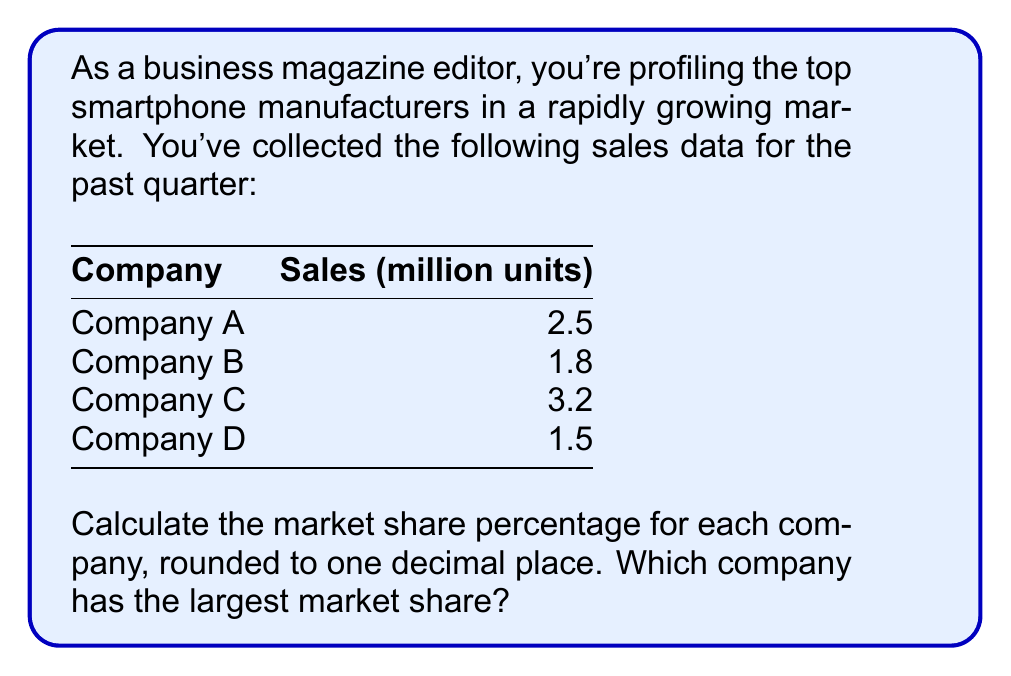Help me with this question. To determine the market share percentages, we'll follow these steps:

1. Calculate the total market size:
   Total units sold = 2.5 + 1.8 + 3.2 + 1.5 = 9 million units

2. Calculate each company's market share using the formula:
   $\text{Market Share (%)} = \frac{\text{Company's Units Sold}}{\text{Total Units Sold}} \times 100\%$

3. For Company A:
   $\text{Market Share A} = \frac{2.5}{9} \times 100\% = 27.77777...\% \approx 27.8\%$

4. For Company B:
   $\text{Market Share B} = \frac{1.8}{9} \times 100\% = 20\%$

5. For Company C:
   $\text{Market Share C} = \frac{3.2}{9} \times 100\% = 35.55555...\% \approx 35.6\%$

6. For Company D:
   $\text{Market Share D} = \frac{1.5}{9} \times 100\% = 16.66666...\% \approx 16.7\%$

7. Comparing the percentages, Company C has the largest market share at 35.6%.
Answer: Company C: 35.6% 